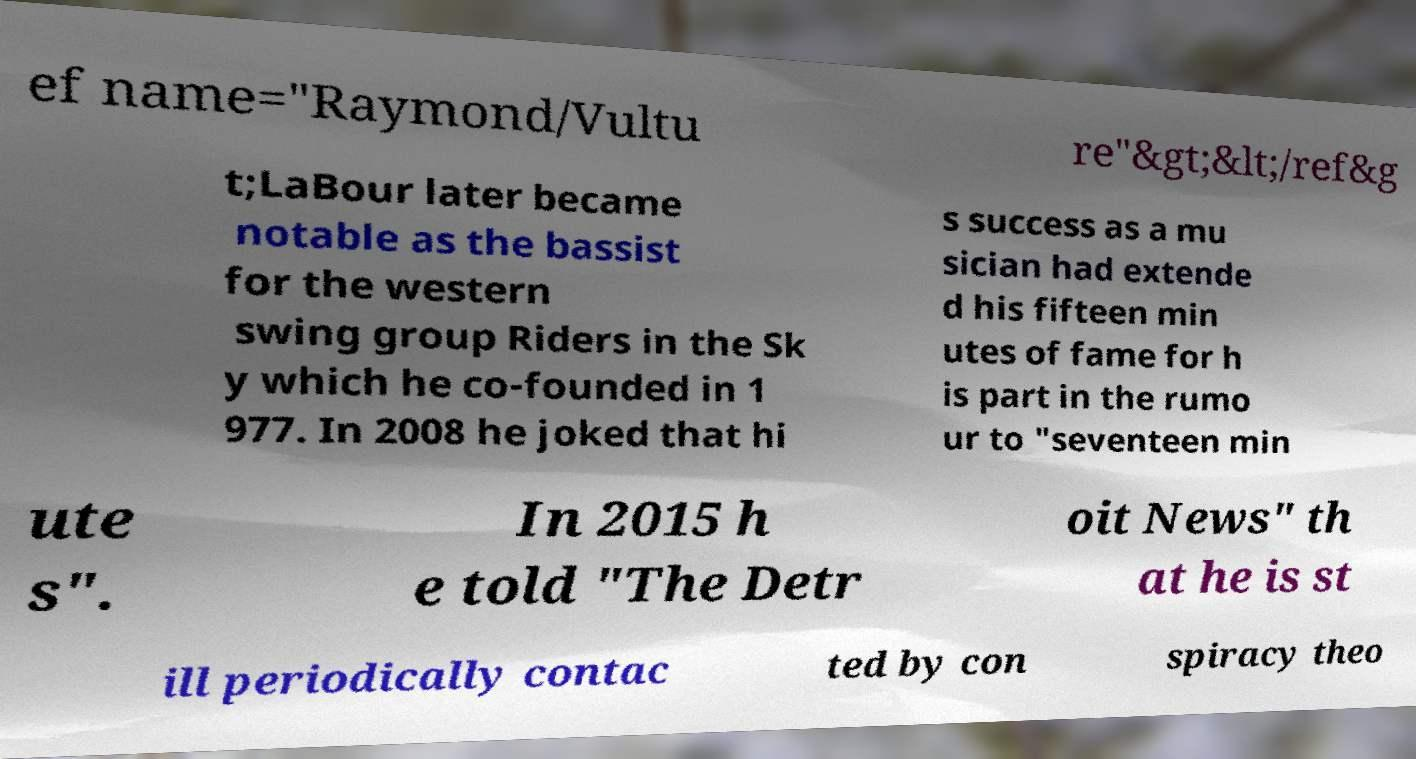For documentation purposes, I need the text within this image transcribed. Could you provide that? ef name="Raymond/Vultu re"&gt;&lt;/ref&g t;LaBour later became notable as the bassist for the western swing group Riders in the Sk y which he co-founded in 1 977. In 2008 he joked that hi s success as a mu sician had extende d his fifteen min utes of fame for h is part in the rumo ur to "seventeen min ute s". In 2015 h e told "The Detr oit News" th at he is st ill periodically contac ted by con spiracy theo 